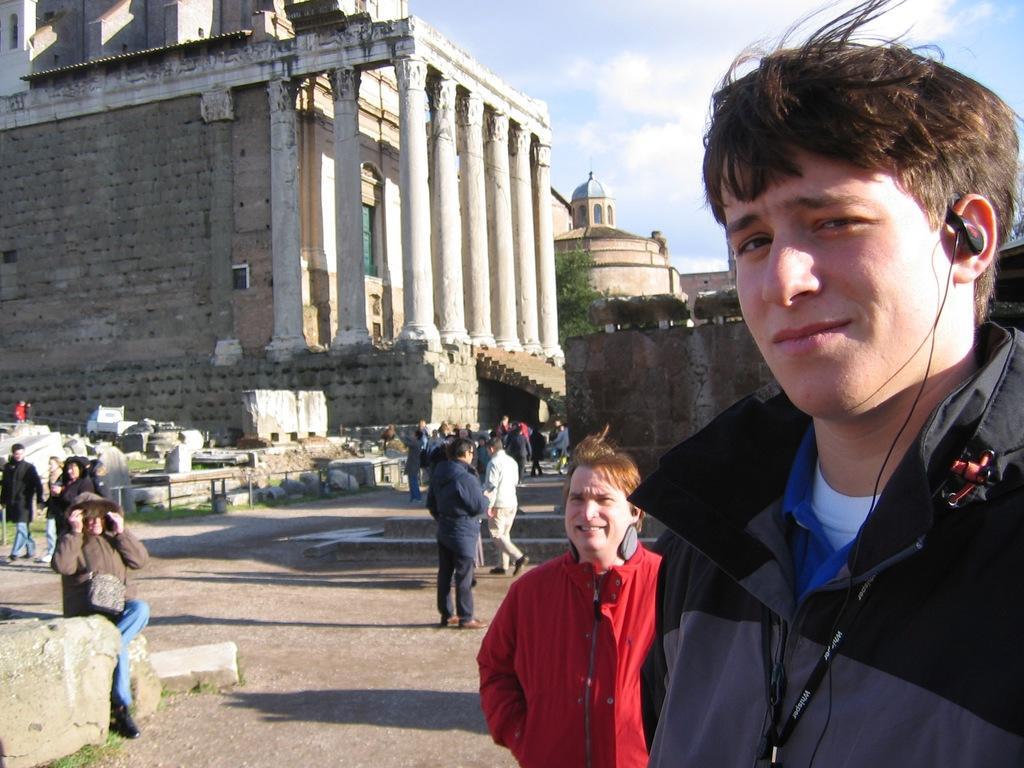Please provide a concise description of this image. In this picture we can see groups of people on the walkway. Behind the people, there are buildings, a tree and the sky. On the left of the image, there are rocks. 